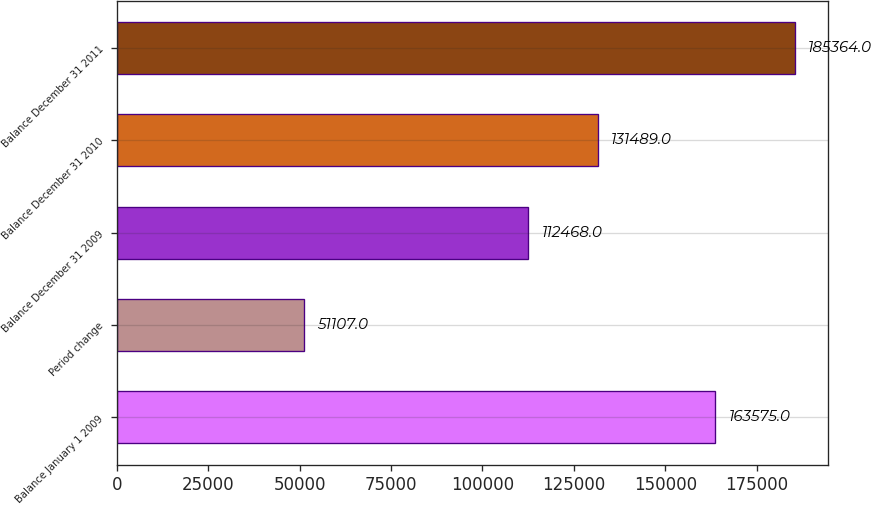Convert chart. <chart><loc_0><loc_0><loc_500><loc_500><bar_chart><fcel>Balance January 1 2009<fcel>Period change<fcel>Balance December 31 2009<fcel>Balance December 31 2010<fcel>Balance December 31 2011<nl><fcel>163575<fcel>51107<fcel>112468<fcel>131489<fcel>185364<nl></chart> 